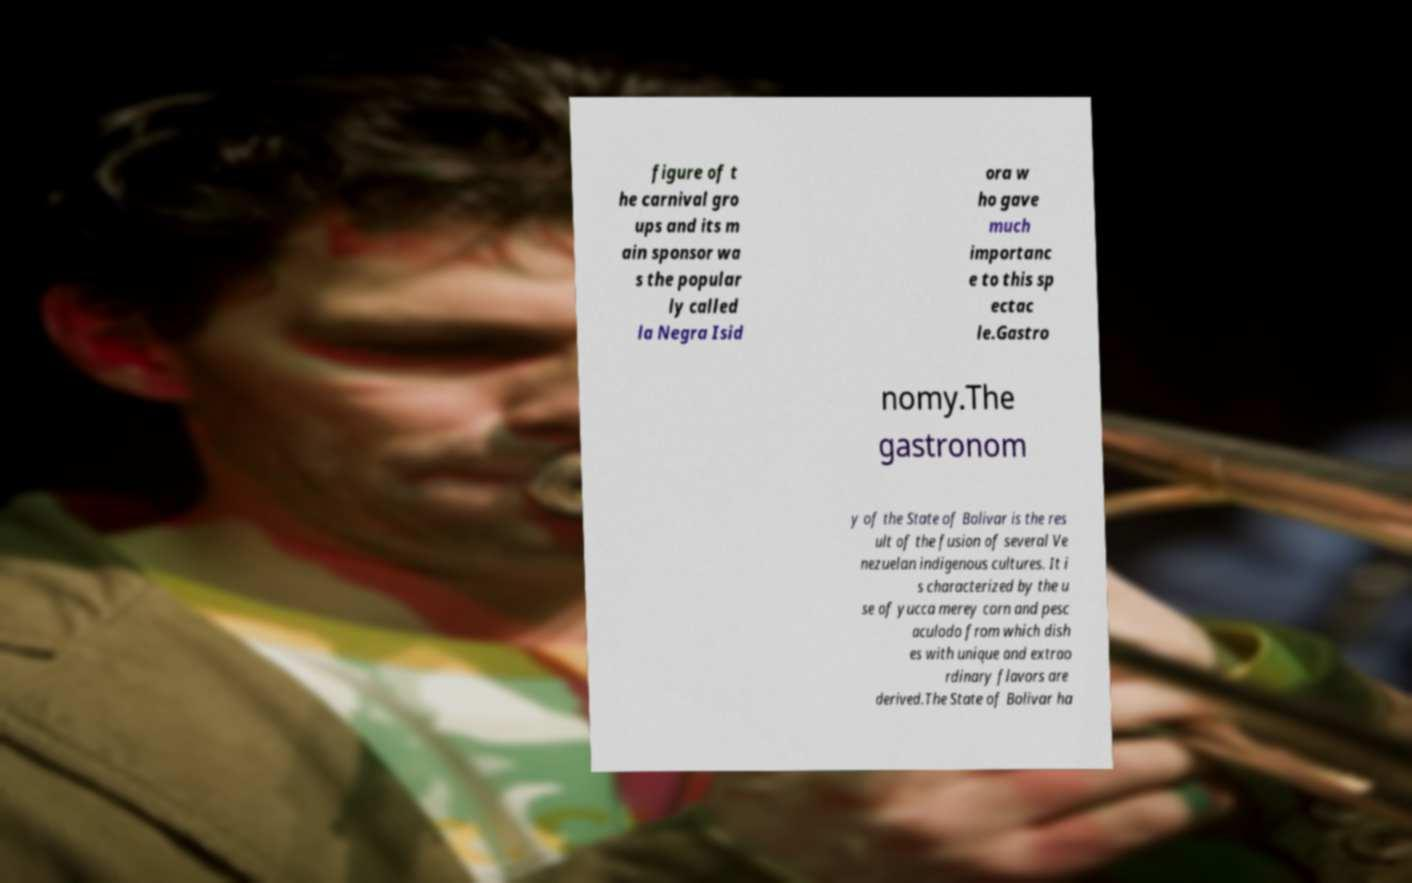Please identify and transcribe the text found in this image. figure of t he carnival gro ups and its m ain sponsor wa s the popular ly called la Negra Isid ora w ho gave much importanc e to this sp ectac le.Gastro nomy.The gastronom y of the State of Bolivar is the res ult of the fusion of several Ve nezuelan indigenous cultures. It i s characterized by the u se of yucca merey corn and pesc aculodo from which dish es with unique and extrao rdinary flavors are derived.The State of Bolivar ha 